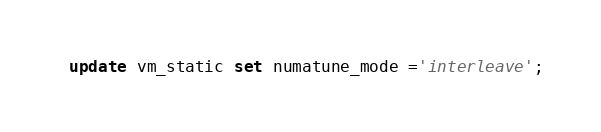Convert code to text. <code><loc_0><loc_0><loc_500><loc_500><_SQL_>update vm_static set numatune_mode ='interleave';

</code> 